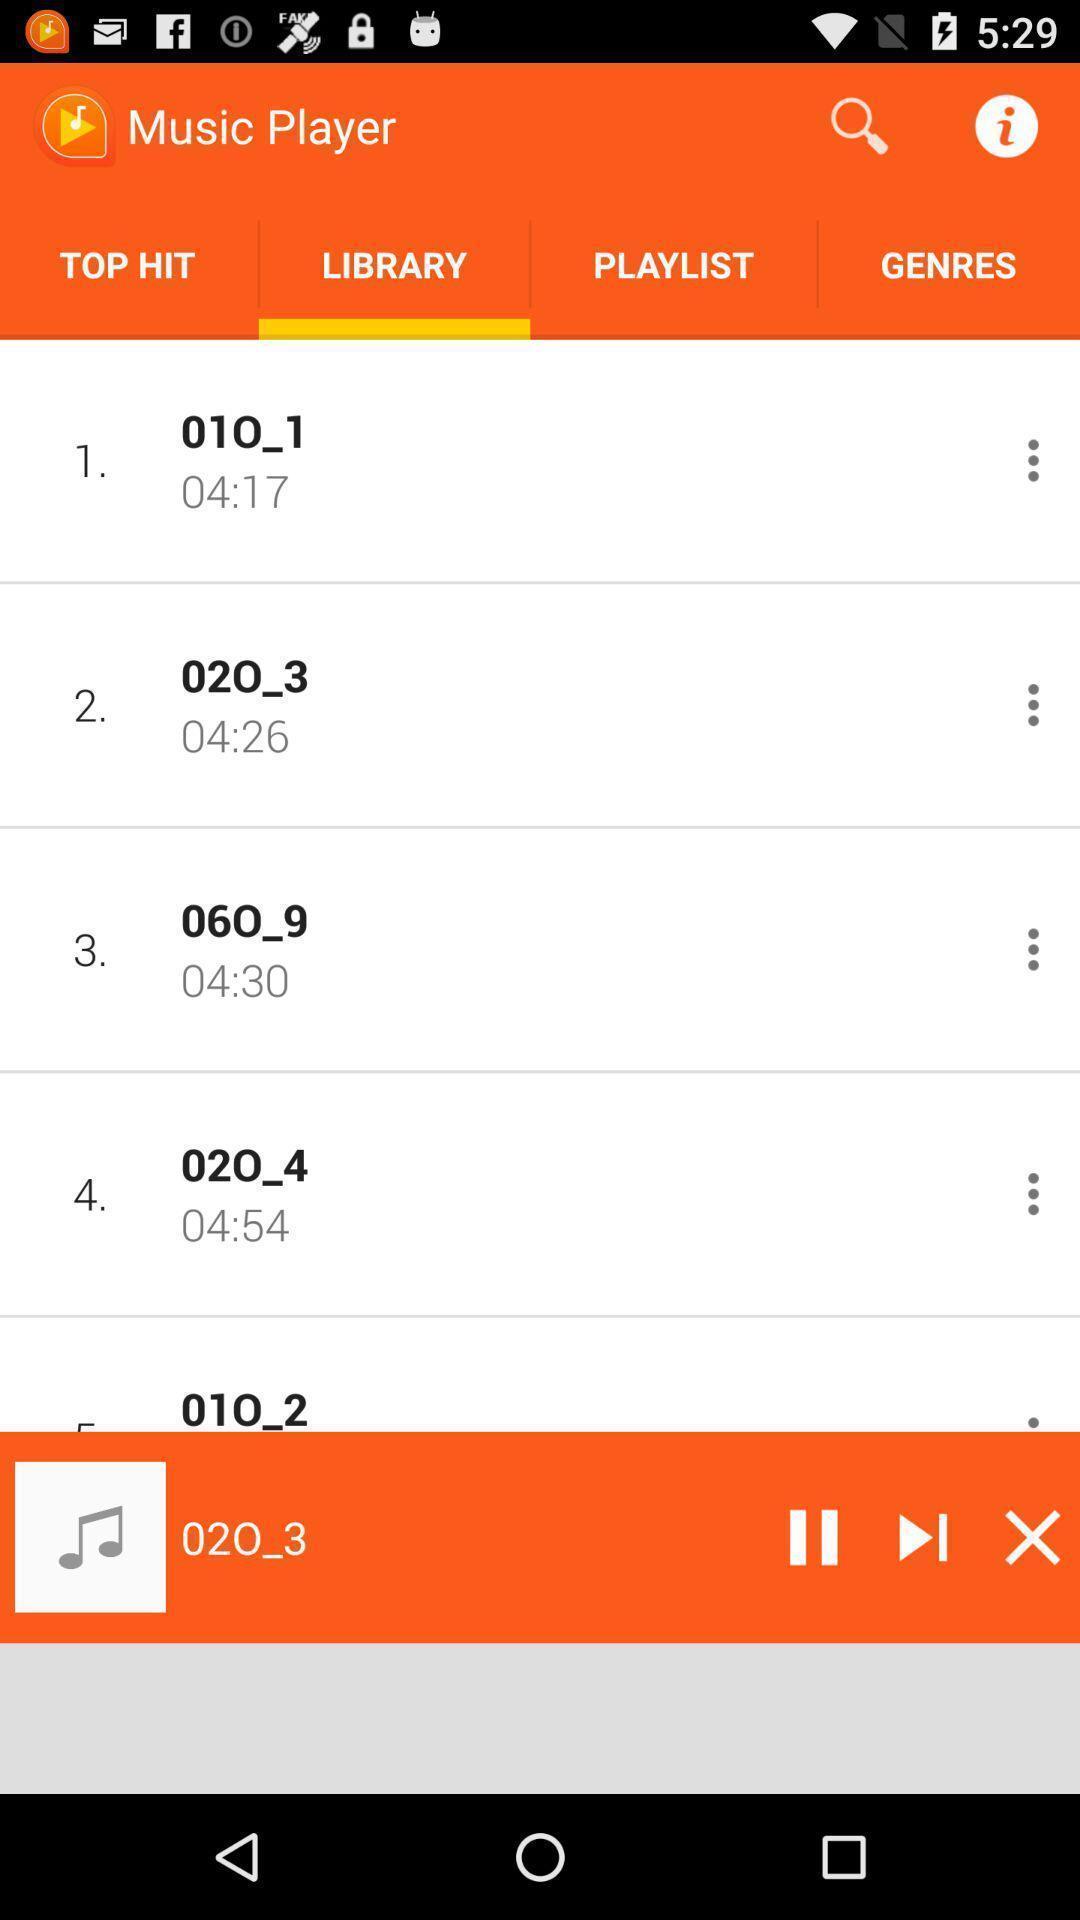Describe the content in this image. Screen displaying library in an music application. 